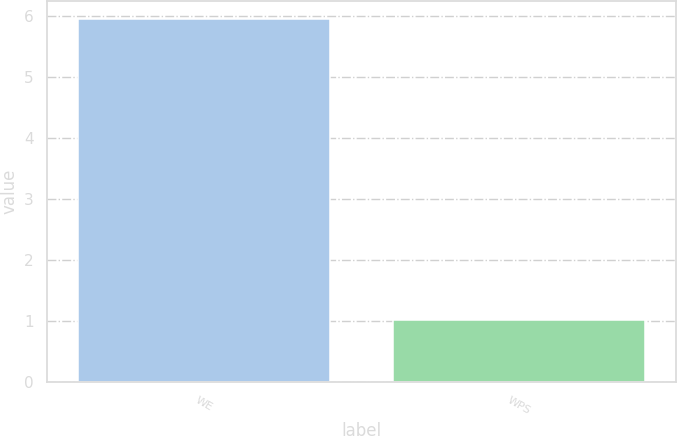Convert chart to OTSL. <chart><loc_0><loc_0><loc_500><loc_500><bar_chart><fcel>WE<fcel>WPS<nl><fcel>5.94<fcel>1.01<nl></chart> 